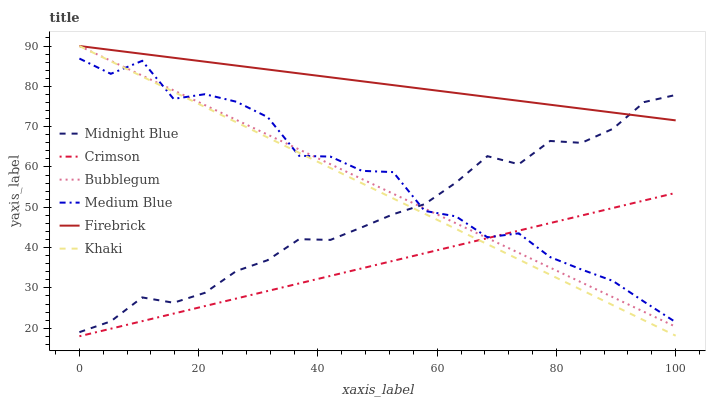Does Crimson have the minimum area under the curve?
Answer yes or no. Yes. Does Firebrick have the maximum area under the curve?
Answer yes or no. Yes. Does Midnight Blue have the minimum area under the curve?
Answer yes or no. No. Does Midnight Blue have the maximum area under the curve?
Answer yes or no. No. Is Firebrick the smoothest?
Answer yes or no. Yes. Is Medium Blue the roughest?
Answer yes or no. Yes. Is Midnight Blue the smoothest?
Answer yes or no. No. Is Midnight Blue the roughest?
Answer yes or no. No. Does Crimson have the lowest value?
Answer yes or no. Yes. Does Midnight Blue have the lowest value?
Answer yes or no. No. Does Bubblegum have the highest value?
Answer yes or no. Yes. Does Midnight Blue have the highest value?
Answer yes or no. No. Is Crimson less than Firebrick?
Answer yes or no. Yes. Is Firebrick greater than Crimson?
Answer yes or no. Yes. Does Crimson intersect Bubblegum?
Answer yes or no. Yes. Is Crimson less than Bubblegum?
Answer yes or no. No. Is Crimson greater than Bubblegum?
Answer yes or no. No. Does Crimson intersect Firebrick?
Answer yes or no. No. 